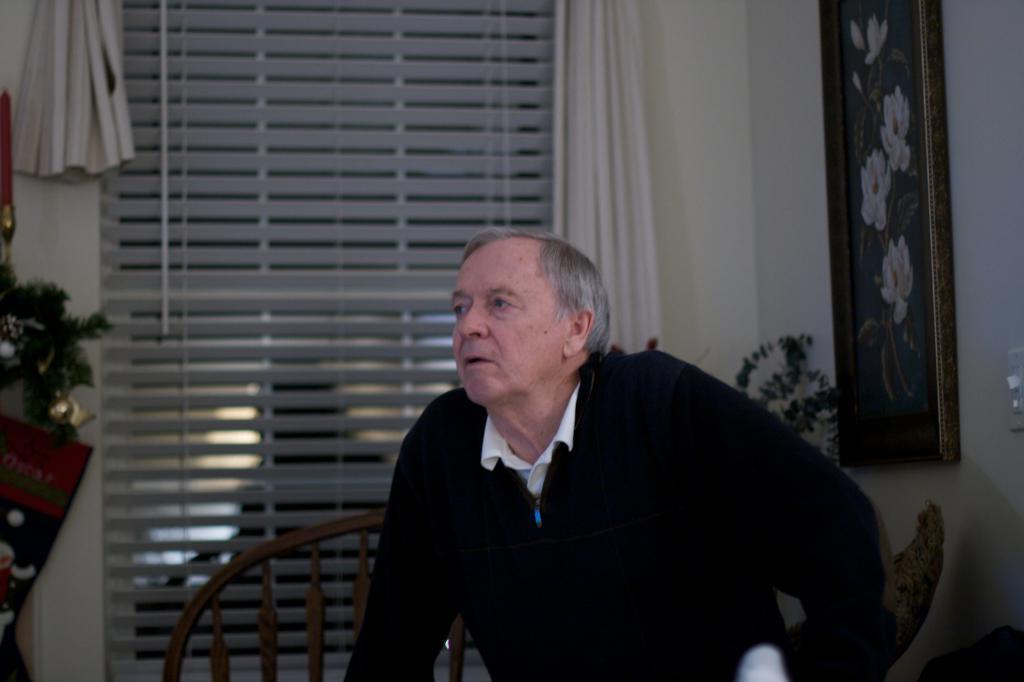Could you give a brief overview of what you see in this image? In this image there is a person sitting on the chair, behind him there is a window and curtains. On the left side of the image there is an object and there are leaves of a plant. On the other side of the image there is a plant and a frame is hanging on the wall. 